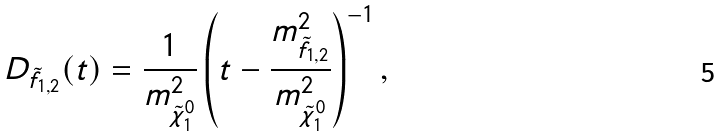Convert formula to latex. <formula><loc_0><loc_0><loc_500><loc_500>D _ { \tilde { f } _ { 1 , 2 } } ( t ) = \frac { 1 } { m _ { \tilde { \chi } _ { 1 } ^ { 0 } } ^ { 2 } } \left ( t - \frac { m _ { \tilde { f } _ { 1 , 2 } } ^ { 2 } } { m _ { \tilde { \chi } _ { 1 } ^ { 0 } } ^ { 2 } } \right ) ^ { - 1 } ,</formula> 